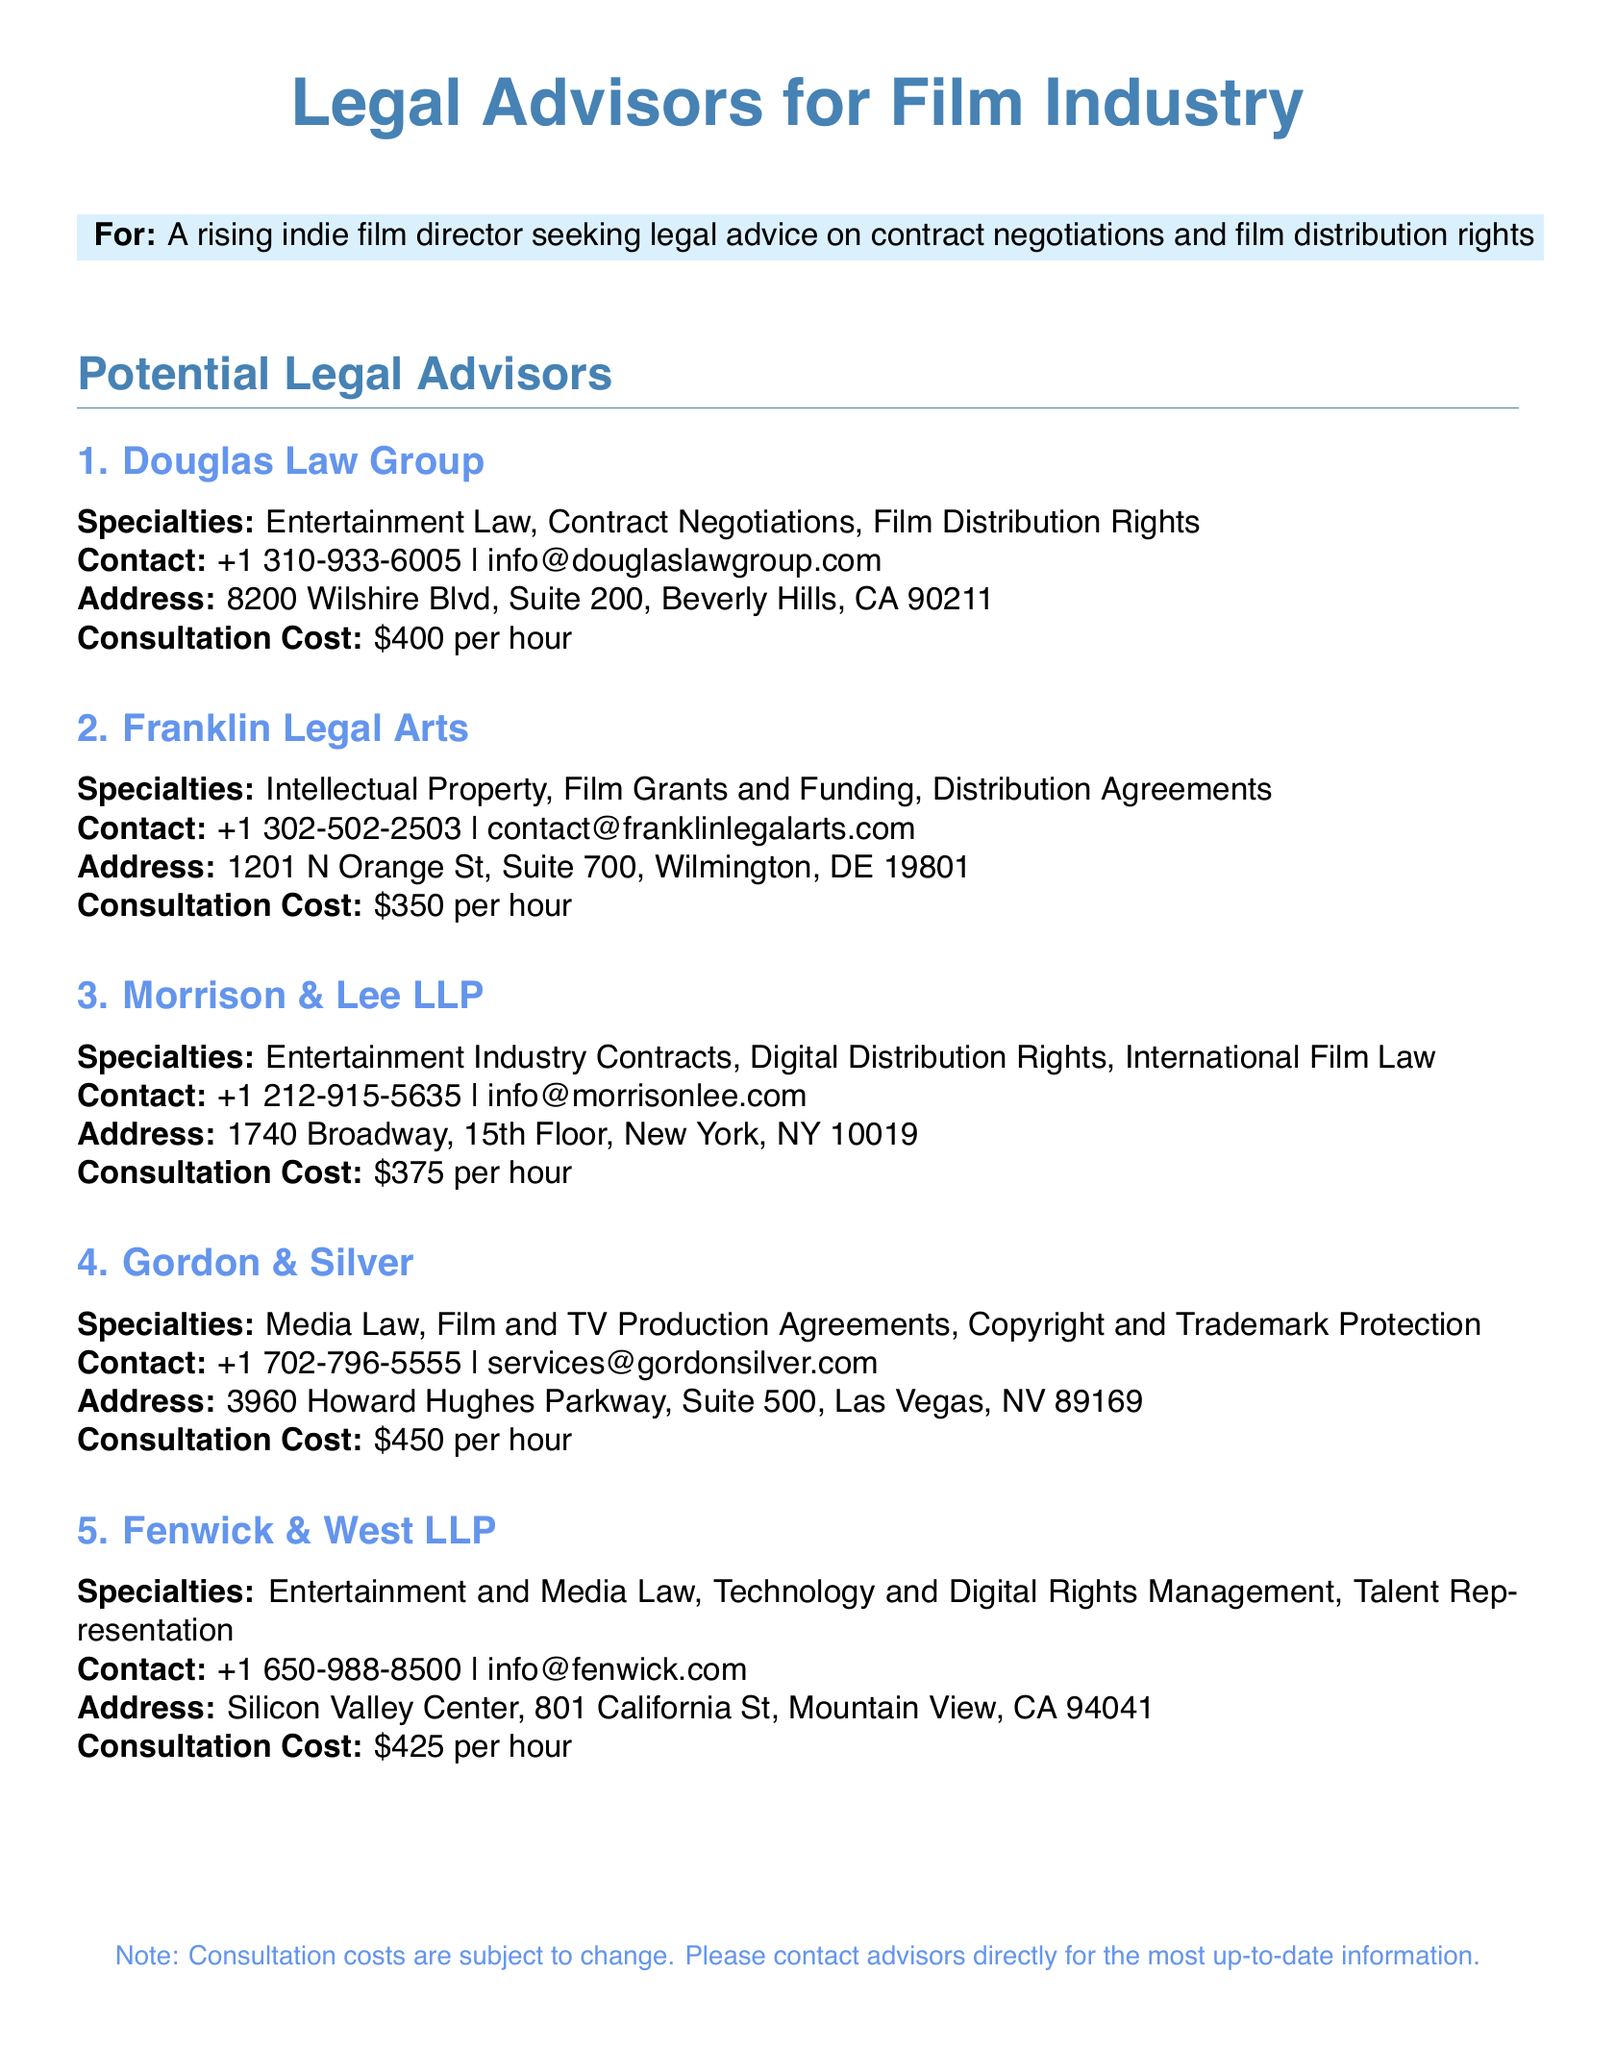What is the contact number for Douglas Law Group? The contact number for Douglas Law Group can be found in the "Contact" section for that advisor.
Answer: +1 310-933-6005 What is the consultation cost for Morrison & Lee LLP? The consultation cost for Morrison & Lee LLP is listed under the "Consultation Cost" section.
Answer: $375 per hour Which legal advisor specializes in Film Grants and Funding? This requires identifying the advisor that lists that specialty in the document.
Answer: Franklin Legal Arts How many legal advisors are listed in the document? This is determined by counting the number of advisors provided in the "Potential Legal Advisors" section.
Answer: 5 What is the address of Fenwick & West LLP? The address can be found in the "Address" section of that advisor's information.
Answer: Silicon Valley Center, 801 California St, Mountain View, CA 94041 Which advisor has the highest consultation cost? This requires comparing all the consultation costs listed for each advisor to find the highest one.
Answer: Gordon & Silver What specialty does Gordon & Silver focus on? The specialty information is clearly mentioned in the description for Gordon & Silver.
Answer: Media Law Does Morrison & Lee LLP provide services related to International Film Law? This question checks the specialty of Morrison & Lee LLP listed in the document.
Answer: Yes 